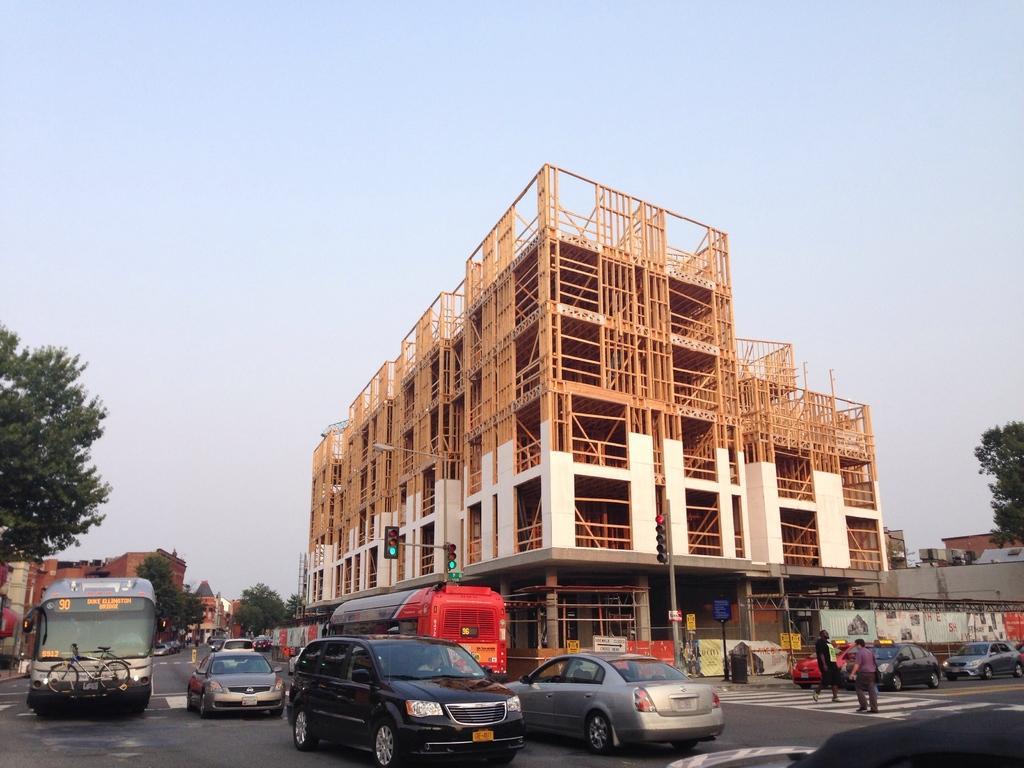How would you summarize this image in a sentence or two? In this image we can see a building. We can also see traffic lights, a pole, a board and some vehicles on the road. On the right side we can see two people on the zebra crossing. On the backside we can see some trees and the sky which looks cloudy. 